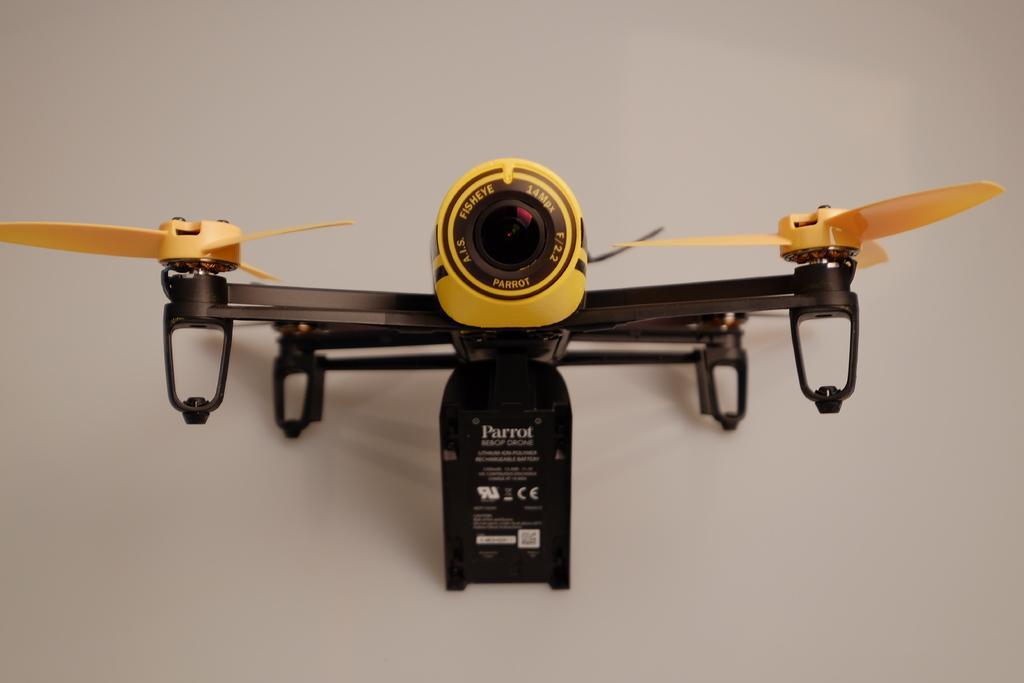In one or two sentences, can you explain what this image depicts? In this image we can see a toy helicopter placed on the surface. 